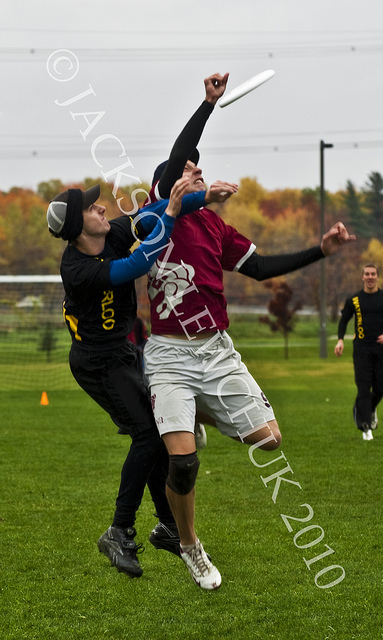Extract all visible text content from this image. RLOO C &#169;JACKSON LEWCHUK 2010 